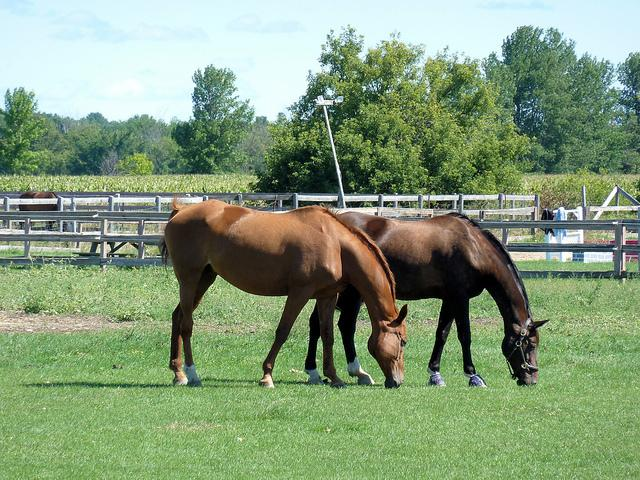Who likely owns these horses? rancher 